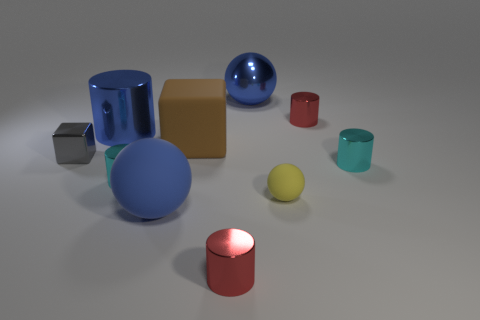Subtract all rubber spheres. How many spheres are left? 1 Subtract 1 balls. How many balls are left? 2 Subtract all green cylinders. How many blue spheres are left? 2 Subtract all gray cubes. How many cubes are left? 1 Add 5 big brown matte blocks. How many big brown matte blocks exist? 6 Subtract 0 purple cubes. How many objects are left? 10 Subtract all blocks. How many objects are left? 8 Subtract all yellow blocks. Subtract all purple cylinders. How many blocks are left? 2 Subtract all large cylinders. Subtract all tiny gray cubes. How many objects are left? 8 Add 7 blue rubber things. How many blue rubber things are left? 8 